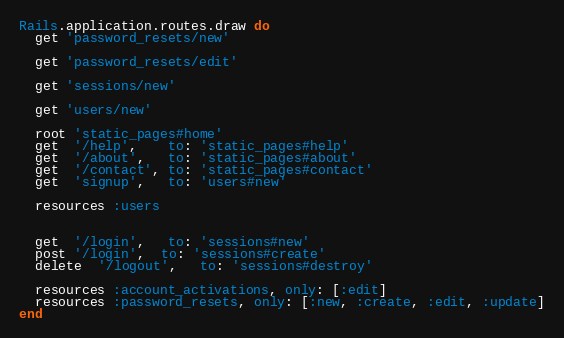Convert code to text. <code><loc_0><loc_0><loc_500><loc_500><_Ruby_>Rails.application.routes.draw do
  get 'password_resets/new'

  get 'password_resets/edit'

  get 'sessions/new'

  get 'users/new'

  root 'static_pages#home'
  get  '/help',    to: 'static_pages#help'
  get  '/about',   to: 'static_pages#about'
  get  '/contact', to: 'static_pages#contact'
  get  'signup',   to: 'users#new'

  resources :users


  get  '/login',   to: 'sessions#new'
  post '/login',  to: 'sessions#create'
  delete  '/logout',   to: 'sessions#destroy'

  resources :account_activations, only: [:edit]
  resources :password_resets, only: [:new, :create, :edit, :update]
end</code> 